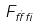<formula> <loc_0><loc_0><loc_500><loc_500>F _ { \dot { \alpha } \beta }</formula> 